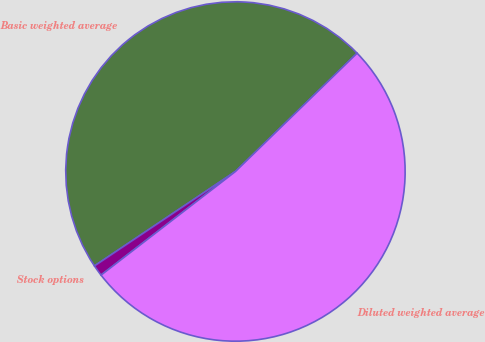Convert chart. <chart><loc_0><loc_0><loc_500><loc_500><pie_chart><fcel>Basic weighted average<fcel>Stock options<fcel>Diluted weighted average<nl><fcel>47.12%<fcel>1.06%<fcel>51.83%<nl></chart> 